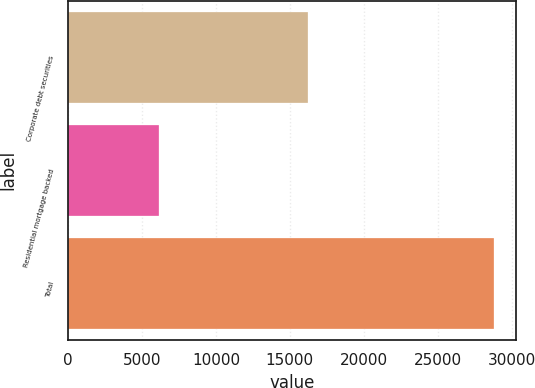<chart> <loc_0><loc_0><loc_500><loc_500><bar_chart><fcel>Corporate debt securities<fcel>Residential mortgage backed<fcel>Total<nl><fcel>16233<fcel>6114<fcel>28839<nl></chart> 